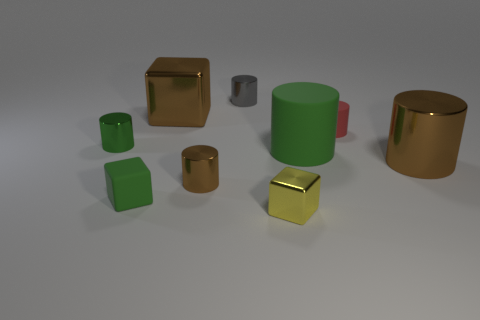Do the tiny rubber cube and the large rubber cylinder have the same color?
Offer a terse response. Yes. What size is the shiny object that is the same color as the large matte thing?
Your answer should be compact. Small. Is there a blue rubber block?
Make the answer very short. No. Do the block behind the tiny green matte object and the tiny yellow thing have the same material?
Your response must be concise. Yes. There is a tiny green object that is the same shape as the big green rubber object; what material is it?
Your response must be concise. Metal. There is a cube that is the same color as the big rubber cylinder; what is it made of?
Ensure brevity in your answer.  Rubber. Are there fewer metallic blocks than tiny gray metallic cylinders?
Provide a succinct answer. No. Does the large cylinder that is behind the large metal cylinder have the same color as the small metallic block?
Your answer should be very brief. No. The small cube that is the same material as the large brown cylinder is what color?
Give a very brief answer. Yellow. Does the yellow thing have the same size as the green shiny cylinder?
Offer a very short reply. Yes. 